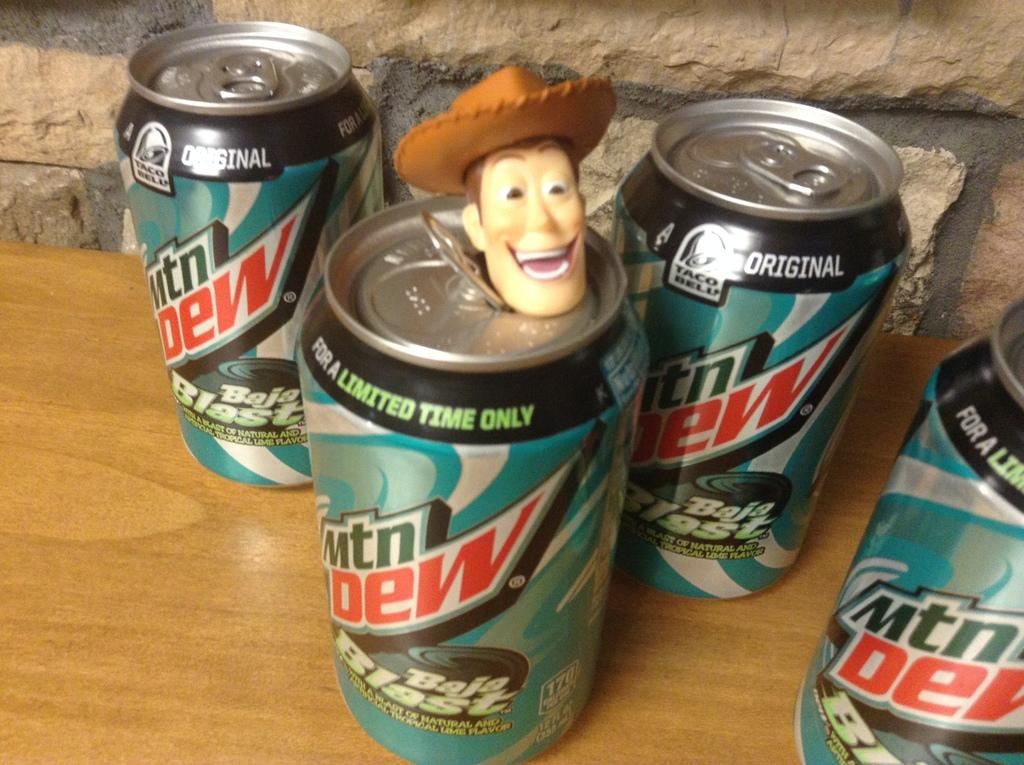<image>
Relay a brief, clear account of the picture shown. Four cans of Mountain Dew one with a Toy Story character emerging from the can. 